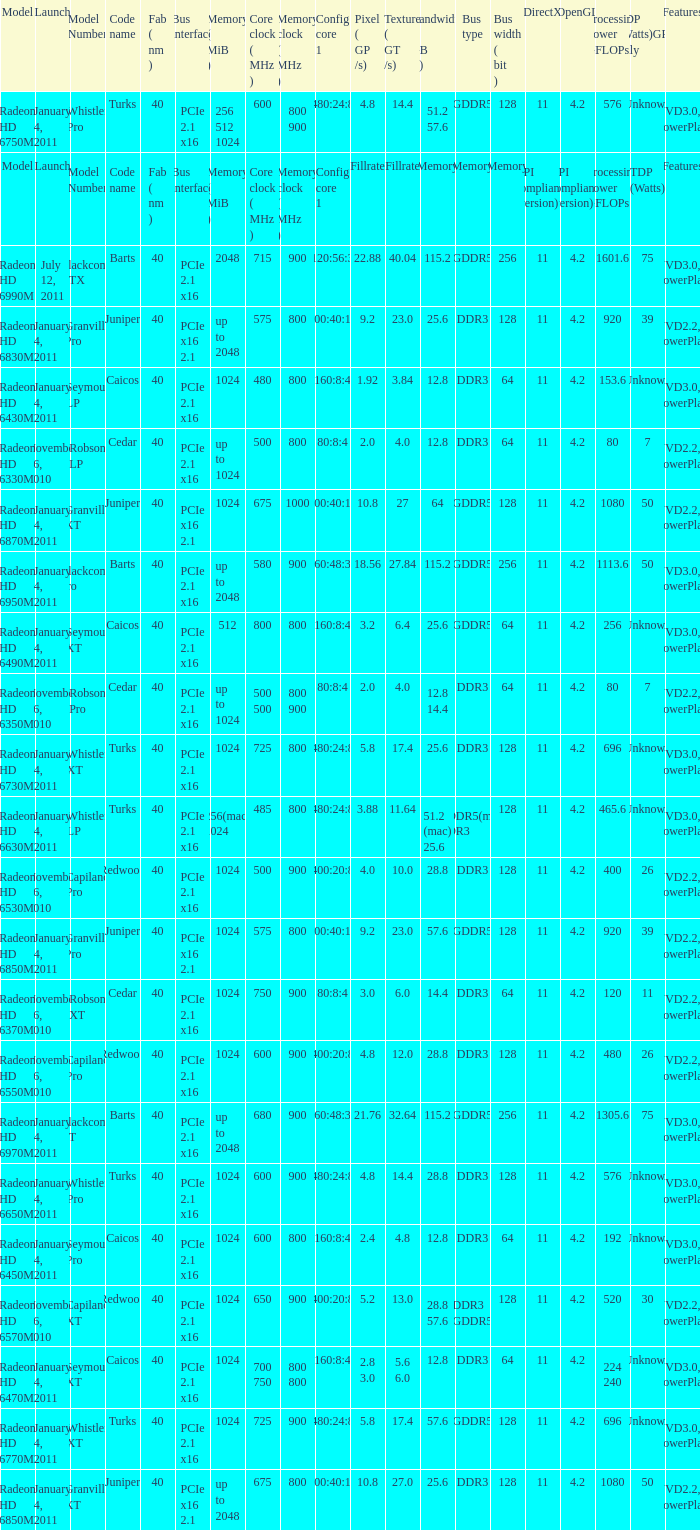What is every code name for the model Radeon HD 6650m? Turks. Give me the full table as a dictionary. {'header': ['Model', 'Launch', 'Model Number', 'Code name', 'Fab ( nm )', 'Bus interface', 'Memory ( MiB )', 'Core clock ( MHz )', 'Memory clock ( MHz )', 'Config core 1', 'Pixel ( GP /s)', 'Texture ( GT /s)', 'Bandwidth ( GB /s)', 'Bus type', 'Bus width ( bit )', 'DirectX', 'OpenGL', 'Processing Power GFLOPs', 'TDP (Watts)GPU only', 'Features'], 'rows': [['Radeon HD 6750M', 'January 4, 2011', 'Whistler Pro', 'Turks', '40', 'PCIe 2.1 x16', '256 512 1024', '600', '800 900', '480:24:8', '4.8', '14.4', '51.2 57.6', 'GDDR5', '128', '11', '4.2', '576', 'Unknown', 'UVD3.0, PowerPlay'], ['Model', 'Launch', 'Model Number', 'Code name', 'Fab ( nm )', 'Bus interface', 'Memory ( MiB )', 'Core clock ( MHz )', 'Memory clock ( MHz )', 'Config core 1', 'Fillrate', 'Fillrate', 'Memory', 'Memory', 'Memory', 'API compliance (version)', 'API compliance (version)', 'Processing Power GFLOPs', 'TDP (Watts)', 'Features'], ['Radeon HD 6990M', 'July 12, 2011', 'Blackcomb XTX', 'Barts', '40', 'PCIe 2.1 x16', '2048', '715', '900', '1120:56:32', '22.88', '40.04', '115.2', 'GDDR5', '256', '11', '4.2', '1601.6', '75', 'UVD3.0, PowerPlay'], ['Radeon HD 6830M', 'January 4, 2011', 'Granville Pro', 'Juniper', '40', 'PCIe x16 2.1', 'up to 2048', '575', '800', '800:40:16', '9.2', '23.0', '25.6', 'DDR3', '128', '11', '4.2', '920', '39', 'UVD2.2, PowerPlay'], ['Radeon HD 6430M', 'January 4, 2011', 'Seymour LP', 'Caicos', '40', 'PCIe 2.1 x16', '1024', '480', '800', '160:8:4', '1.92', '3.84', '12.8', 'DDR3', '64', '11', '4.2', '153.6', 'Unknown', 'UVD3.0, PowerPlay'], ['Radeon HD 6330M', 'November 26, 2010', 'Robson LP', 'Cedar', '40', 'PCIe 2.1 x16', 'up to 1024', '500', '800', '80:8:4', '2.0', '4.0', '12.8', 'DDR3', '64', '11', '4.2', '80', '7', 'UVD2.2, PowerPlay'], ['Radeon HD 6870M', 'January 4, 2011', 'Granville XT', 'Juniper', '40', 'PCIe x16 2.1', '1024', '675', '1000', '800:40:16', '10.8', '27', '64', 'GDDR5', '128', '11', '4.2', '1080', '50', 'UVD2.2, PowerPlay'], ['Radeon HD 6950M', 'January 4, 2011', 'Blackcomb Pro', 'Barts', '40', 'PCIe 2.1 x16', 'up to 2048', '580', '900', '960:48:32', '18.56', '27.84', '115.2', 'GDDR5', '256', '11', '4.2', '1113.6', '50', 'UVD3.0, PowerPlay'], ['Radeon HD 6490M', 'January 4, 2011', 'Seymour XT', 'Caicos', '40', 'PCIe 2.1 x16', '512', '800', '800', '160:8:4', '3.2', '6.4', '25.6', 'GDDR5', '64', '11', '4.2', '256', 'Unknown', 'UVD3.0, PowerPlay'], ['Radeon HD 6350M', 'November 26, 2010', 'Robson Pro', 'Cedar', '40', 'PCIe 2.1 x16', 'up to 1024', '500 500', '800 900', '80:8:4', '2.0', '4.0', '12.8 14.4', 'DDR3', '64', '11', '4.2', '80', '7', 'UVD2.2, PowerPlay'], ['Radeon HD 6730M', 'January 4, 2011', 'Whistler XT', 'Turks', '40', 'PCIe 2.1 x16', '1024', '725', '800', '480:24:8', '5.8', '17.4', '25.6', 'DDR3', '128', '11', '4.2', '696', 'Unknown', 'UVD3.0, PowerPlay'], ['Radeon HD 6630M', 'January 4, 2011', 'Whistler LP', 'Turks', '40', 'PCIe 2.1 x16', '256(mac) 1024', '485', '800', '480:24:8', '3.88', '11.64', '51.2 (mac) 25.6', 'GDDR5(mac) DDR3', '128', '11', '4.2', '465.6', 'Unknown', 'UVD3.0, PowerPlay'], ['Radeon HD 6530M', 'November 26, 2010', 'Capilano Pro', 'Redwood', '40', 'PCIe 2.1 x16', '1024', '500', '900', '400:20:8', '4.0', '10.0', '28.8', 'DDR3', '128', '11', '4.2', '400', '26', 'UVD2.2, PowerPlay'], ['Radeon HD 6850M', 'January 4, 2011', 'Granville Pro', 'Juniper', '40', 'PCIe x16 2.1', '1024', '575', '800', '800:40:16', '9.2', '23.0', '57.6', 'GDDR5', '128', '11', '4.2', '920', '39', 'UVD2.2, PowerPlay'], ['Radeon HD 6370M', 'November 26, 2010', 'Robson XT', 'Cedar', '40', 'PCIe 2.1 x16', '1024', '750', '900', '80:8:4', '3.0', '6.0', '14.4', 'DDR3', '64', '11', '4.2', '120', '11', 'UVD2.2, PowerPlay'], ['Radeon HD 6550M', 'November 26, 2010', 'Capilano Pro', 'Redwood', '40', 'PCIe 2.1 x16', '1024', '600', '900', '400:20:8', '4.8', '12.0', '28.8', 'DDR3', '128', '11', '4.2', '480', '26', 'UVD2.2, PowerPlay'], ['Radeon HD 6970M', 'January 4, 2011', 'Blackcomb XT', 'Barts', '40', 'PCIe 2.1 x16', 'up to 2048', '680', '900', '960:48:32', '21.76', '32.64', '115.2', 'GDDR5', '256', '11', '4.2', '1305.6', '75', 'UVD3.0, PowerPlay'], ['Radeon HD 6650M', 'January 4, 2011', 'Whistler Pro', 'Turks', '40', 'PCIe 2.1 x16', '1024', '600', '900', '480:24:8', '4.8', '14.4', '28.8', 'DDR3', '128', '11', '4.2', '576', 'Unknown', 'UVD3.0, PowerPlay'], ['Radeon HD 6450M', 'January 4, 2011', 'Seymour Pro', 'Caicos', '40', 'PCIe 2.1 x16', '1024', '600', '800', '160:8:4', '2.4', '4.8', '12.8', 'DDR3', '64', '11', '4.2', '192', 'Unknown', 'UVD3.0, PowerPlay'], ['Radeon HD 6570M', 'November 26, 2010', 'Capilano XT', 'Redwood', '40', 'PCIe 2.1 x16', '1024', '650', '900', '400:20:8', '5.2', '13.0', '28.8 57.6', 'DDR3 GDDR5', '128', '11', '4.2', '520', '30', 'UVD2.2, PowerPlay'], ['Radeon HD 6470M', 'January 4, 2011', 'Seymour XT', 'Caicos', '40', 'PCIe 2.1 x16', '1024', '700 750', '800 800', '160:8:4', '2.8 3.0', '5.6 6.0', '12.8', 'DDR3', '64', '11', '4.2', '224 240', 'Unknown', 'UVD3.0, PowerPlay'], ['Radeon HD 6770M', 'January 4, 2011', 'Whistler XT', 'Turks', '40', 'PCIe 2.1 x16', '1024', '725', '900', '480:24:8', '5.8', '17.4', '57.6', 'GDDR5', '128', '11', '4.2', '696', 'Unknown', 'UVD3.0, PowerPlay'], ['Radeon HD 6850M', 'January 4, 2011', 'Granville XT', 'Juniper', '40', 'PCIe x16 2.1', 'up to 2048', '675', '800', '800:40:16', '10.8', '27.0', '25.6', 'DDR3', '128', '11', '4.2', '1080', '50', 'UVD2.2, PowerPlay']]} 